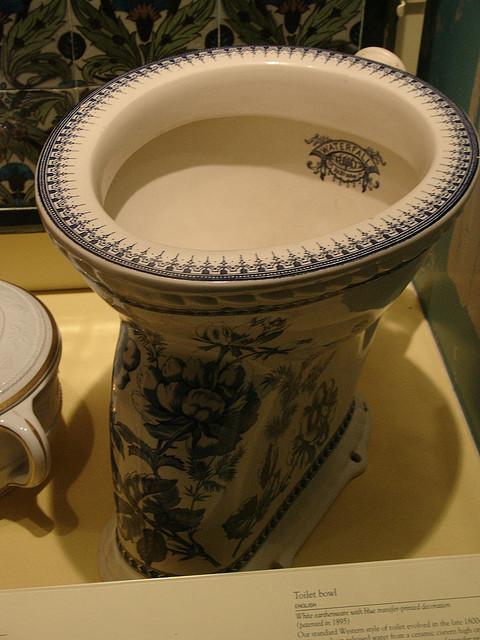What is the object shown in the picture?
Write a very short answer. Toilet. What color is the print on this piece?
Write a very short answer. Blue. What is the white and blue object made of?
Be succinct. Porcelain. 